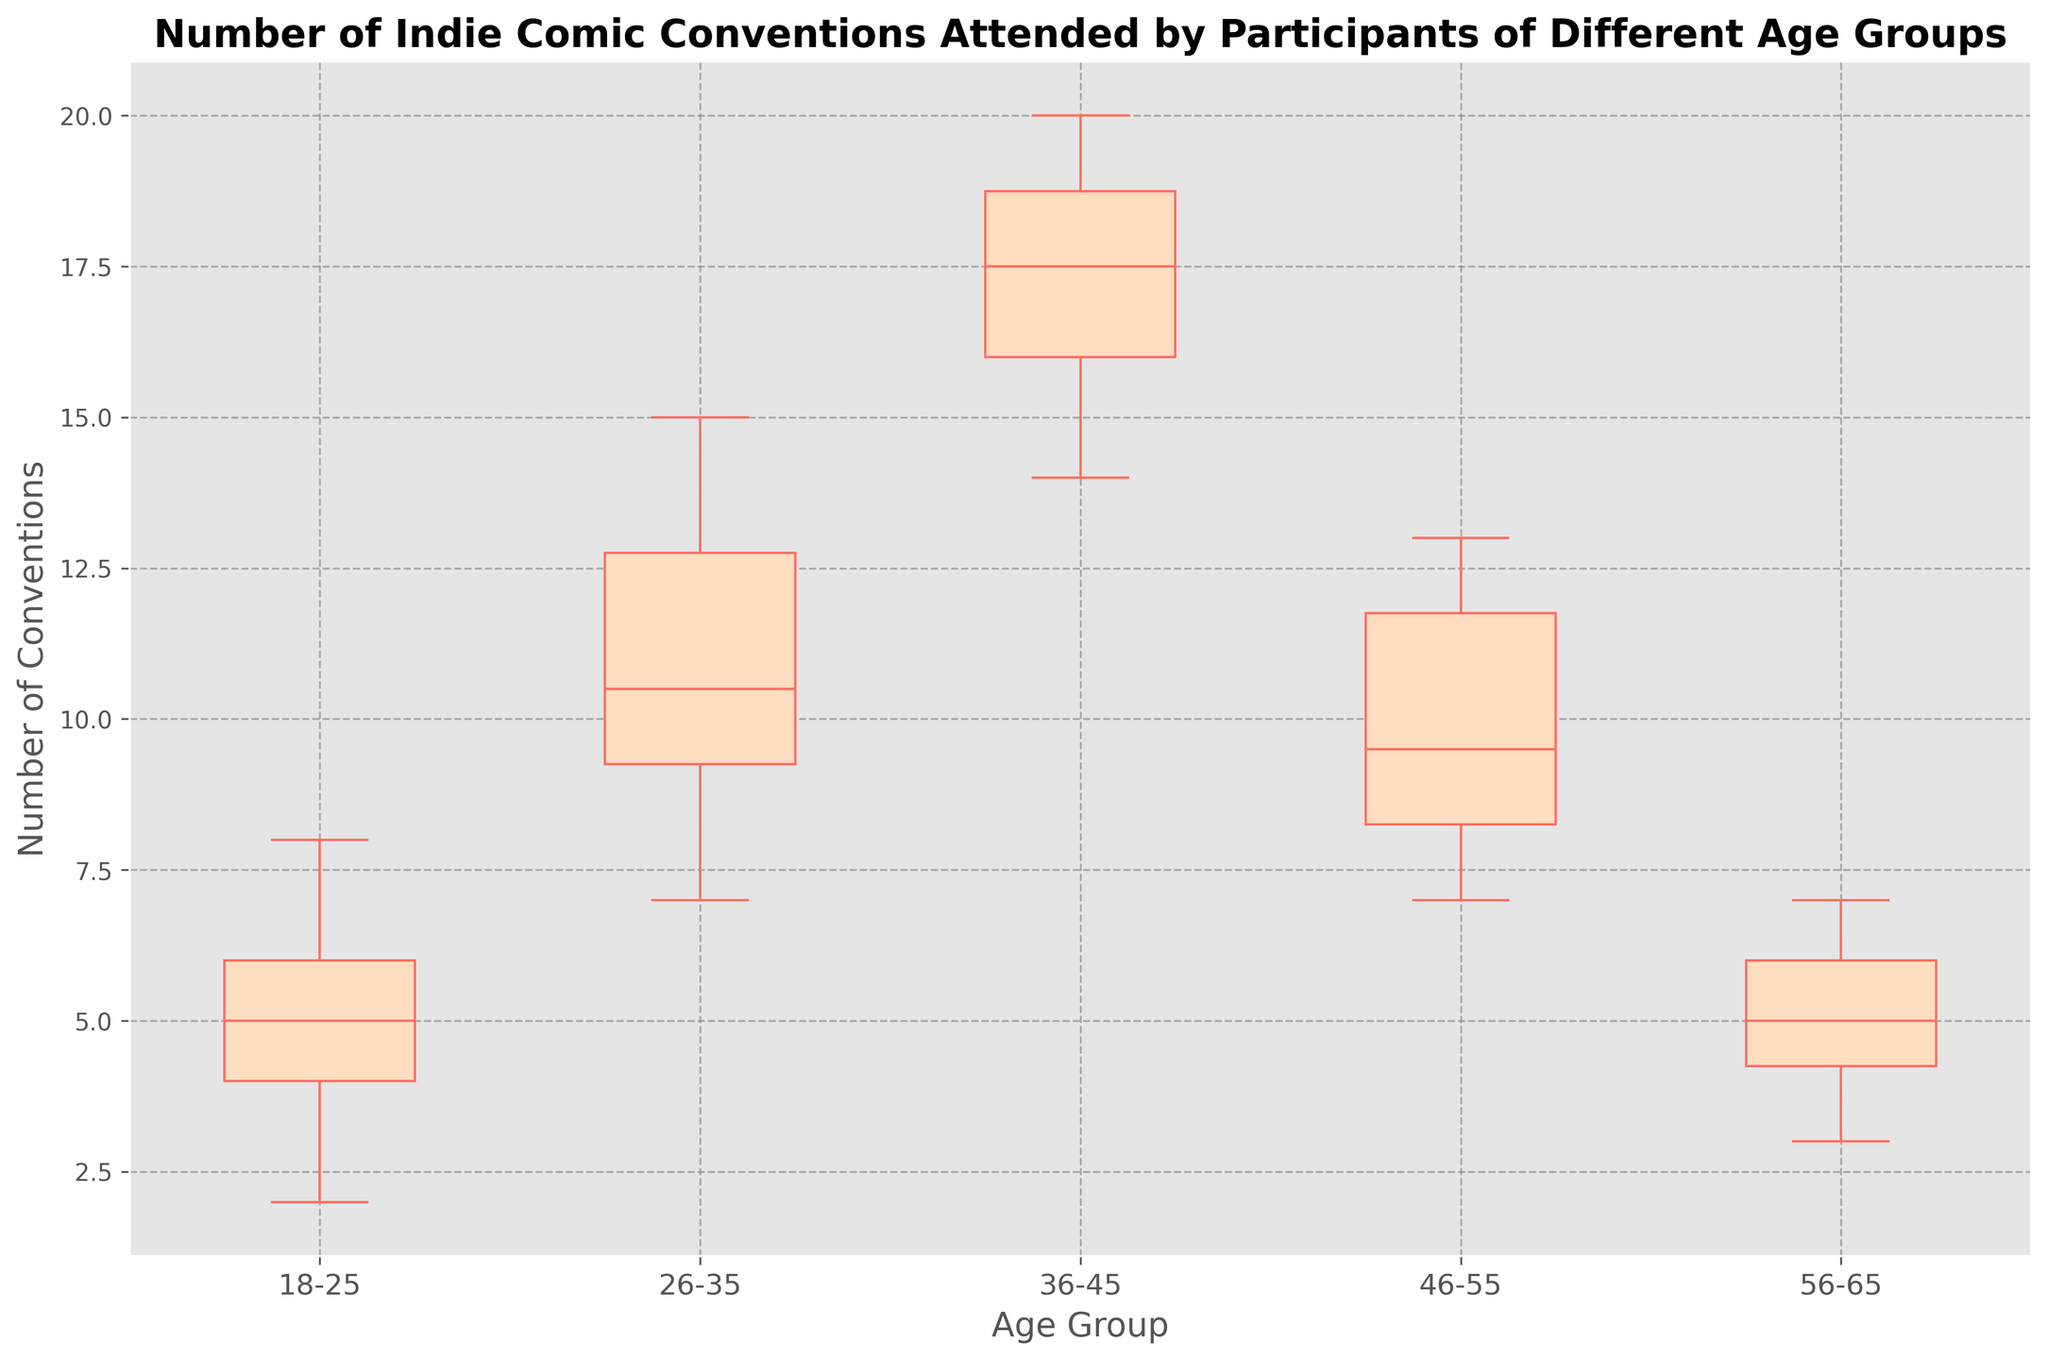What is the median number of conventions attended by the 18-25 age group? To find the median, look at the middle value when the numbers are ordered. For 18-25: (2, 3, 4, 4, 5, 5, 6, 6, 7, 8). The median is the average of the 5th and 6th values, which is (5+5)/2.
Answer: 5 Which age group attended the most conventions on average? Calculate the average number of conventions for each age group by summing their values and dividing by the count of values. 18-25: (4+7+5+6+2+4+3+8+6+5)/10 = 50/10 = 5, etc. Comparing all, 36-45 has the highest average.
Answer: 36-45 What is the interquartile range (IQR) for the 46-55 age group? IQR is the difference between the first (Q1) and third quartile (Q3). For 46-55: Ordered data is (7, 8, 8, 9, 9, 10, 11, 12, 12, 13). Q1 is the 3rd value (8) and Q3 is the 8th (12). IQR = 12 - 8 = 4.
Answer: 4 Which group has the widest spread in the number of conventions attended? By looking at the range from the minimum to the maximum values in each box plot, the 36-45 age group spans from 14 to 20, which is the widest.
Answer: 36-45 Are there any outliers in the 18-25 age group, and if so, what are they? Outliers are typically represented by points outside the whiskers. Checking the box plot, if any points lie outside the whiskers, they are outliers. For 18-25, there are no points distinctly outside the whiskers.
Answer: No outliers What is the range of conventions attended by the 56-65 age group? The range is the difference between the maximum and minimum values. For 56-65: Ordered data is (3, 4, 4, 5, 5, 5, 6, 6, 7, 7). Max is 7 and min is 3, so range = 7 - 3 = 4.
Answer: 4 Which age group shows the greatest variability in the number of conventions attended? Variability can be inferred from the length of the box and whiskers. The 36-45 and 26-35 groups have larger spreads, but 36-45 shows more consistency overall, meaning 26-35 likely has greater variability.
Answer: 26-35 